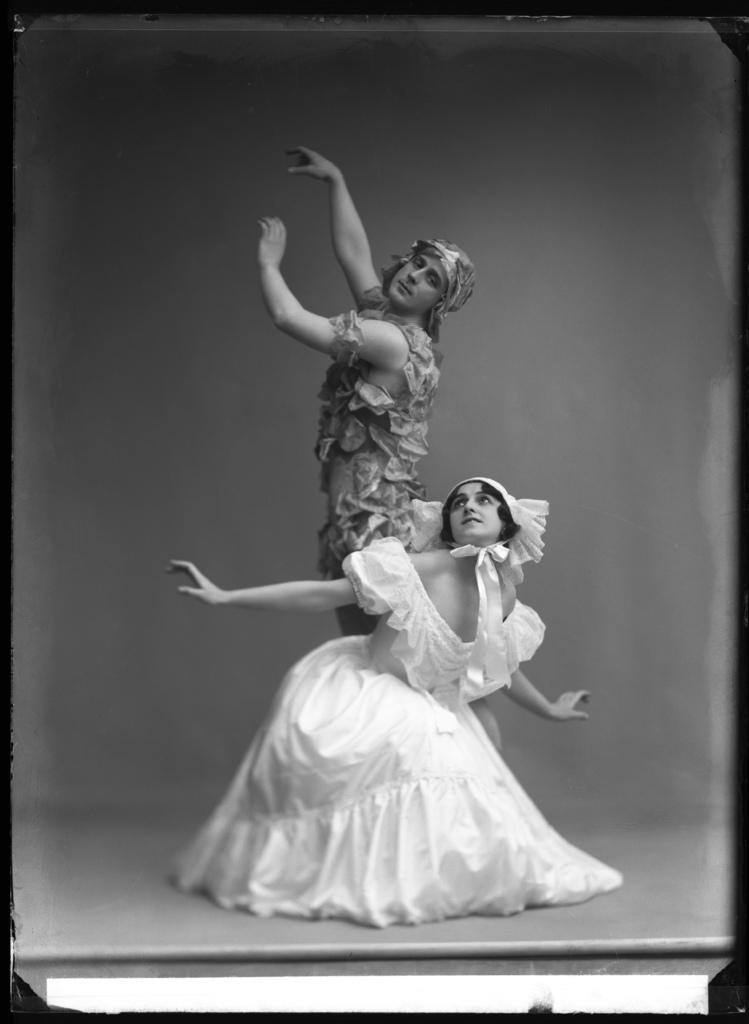Can you describe this image briefly? In this picture we can see a man and a woman, they are wearing costumes, it is a black and white image. 